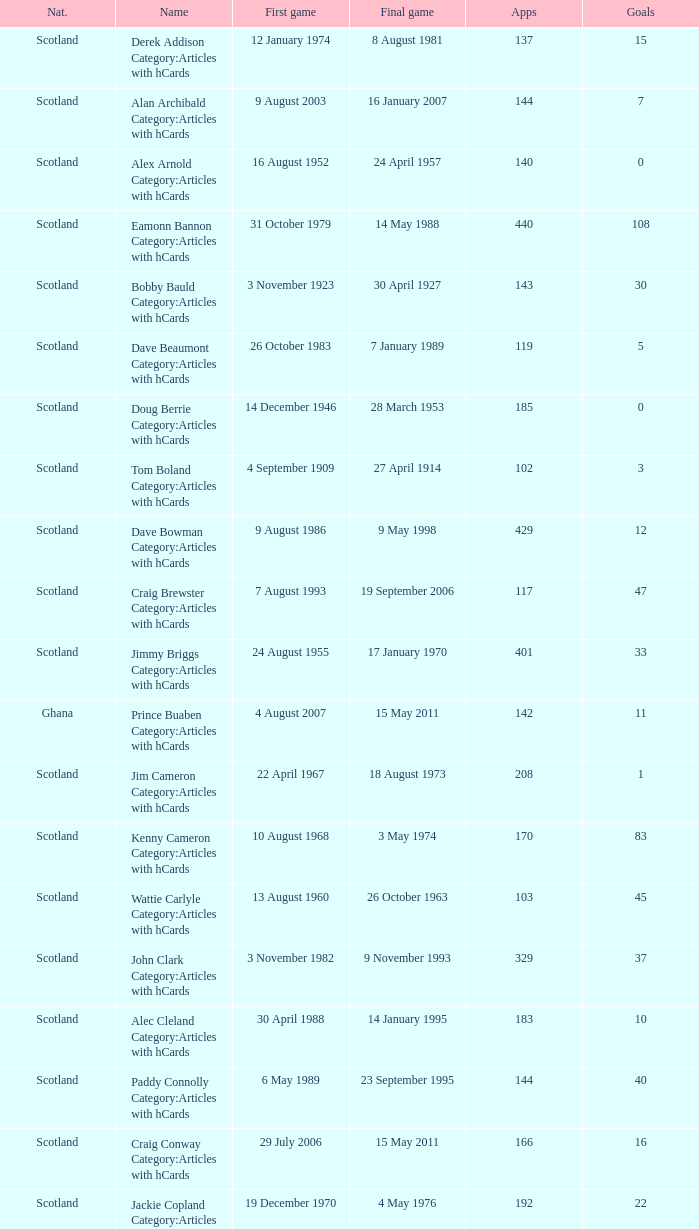What name has 118 as the apps? Ron Yeats Category:Articles with hCards. 